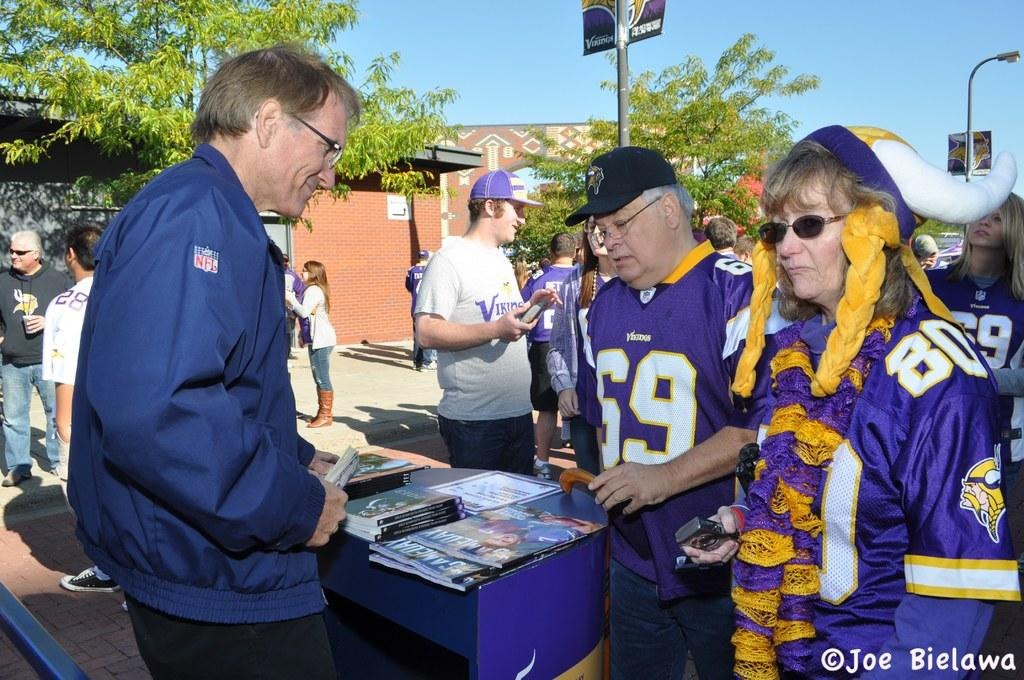<image>
Give a short and clear explanation of the subsequent image. A group of Vikings fans at an outdoor event next to a table where a man is selling books and magazines. 